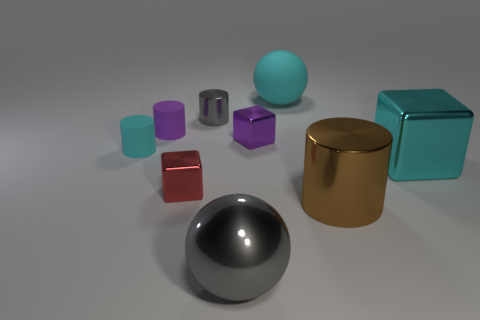Subtract all small cubes. How many cubes are left? 1 Subtract 1 cylinders. How many cylinders are left? 3 Add 1 tiny blocks. How many objects exist? 10 Subtract all cyan cylinders. How many cylinders are left? 3 Subtract all red cylinders. Subtract all blue blocks. How many cylinders are left? 4 Subtract all cylinders. How many objects are left? 5 Subtract all brown objects. Subtract all tiny objects. How many objects are left? 3 Add 8 large cyan metal blocks. How many large cyan metal blocks are left? 9 Add 5 cyan cubes. How many cyan cubes exist? 6 Subtract 0 gray cubes. How many objects are left? 9 